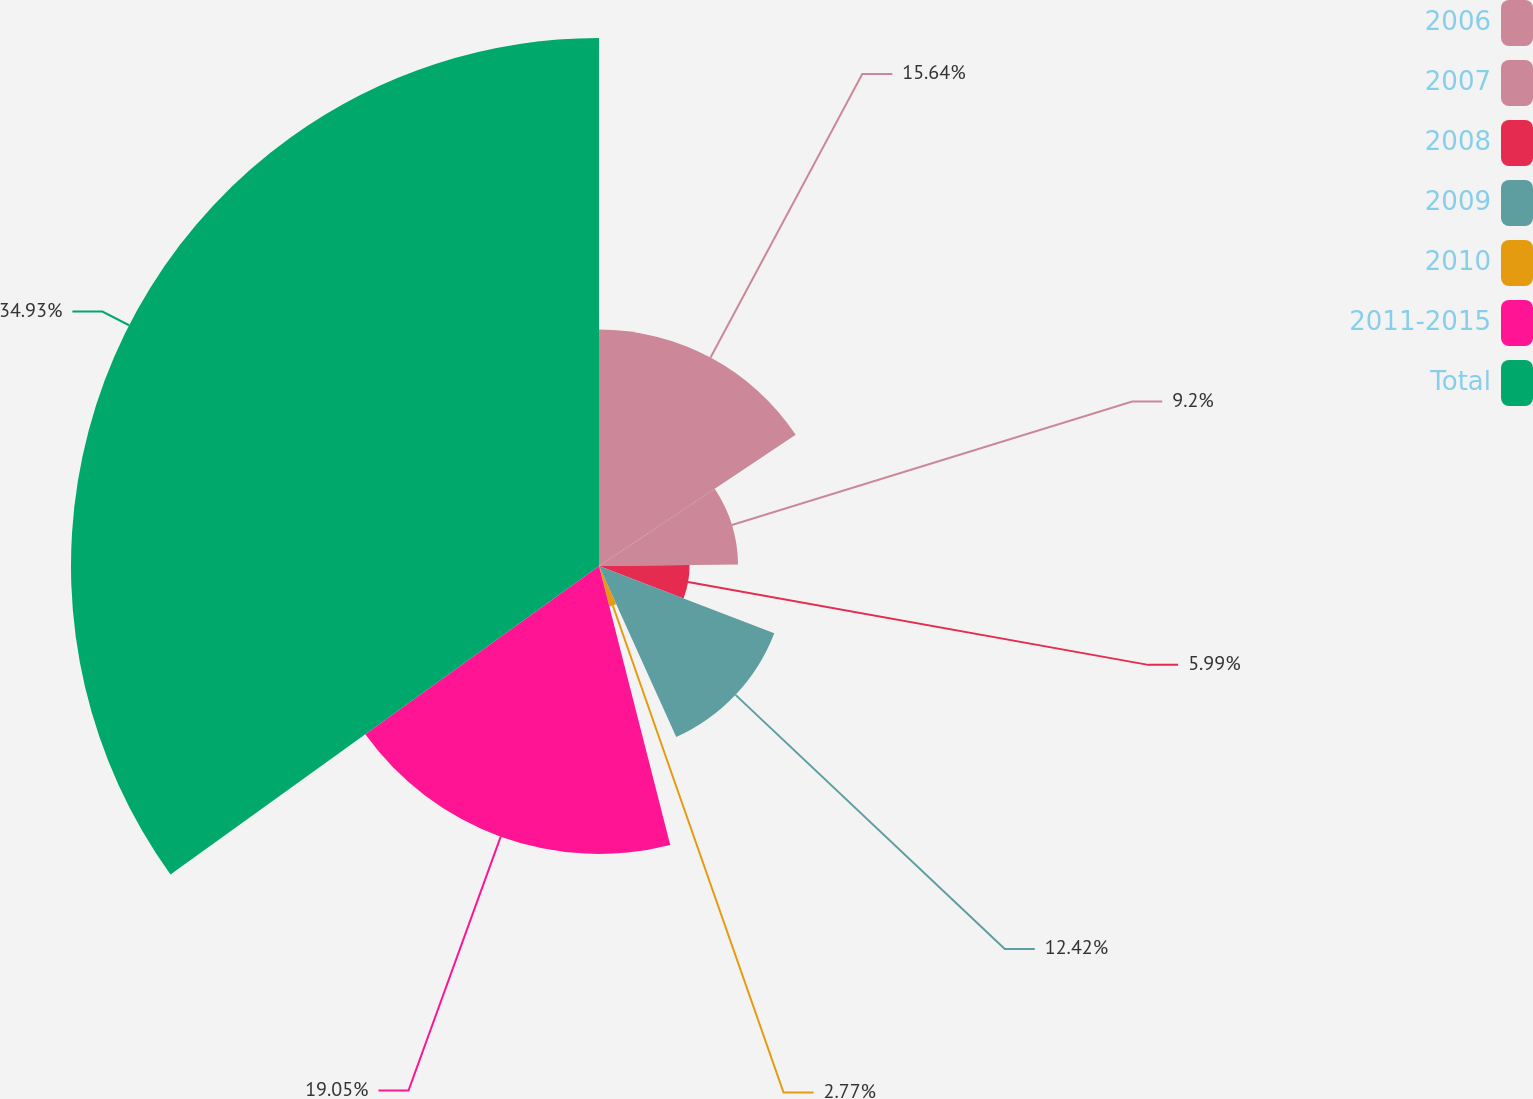<chart> <loc_0><loc_0><loc_500><loc_500><pie_chart><fcel>2006<fcel>2007<fcel>2008<fcel>2009<fcel>2010<fcel>2011-2015<fcel>Total<nl><fcel>15.64%<fcel>9.2%<fcel>5.99%<fcel>12.42%<fcel>2.77%<fcel>19.05%<fcel>34.93%<nl></chart> 